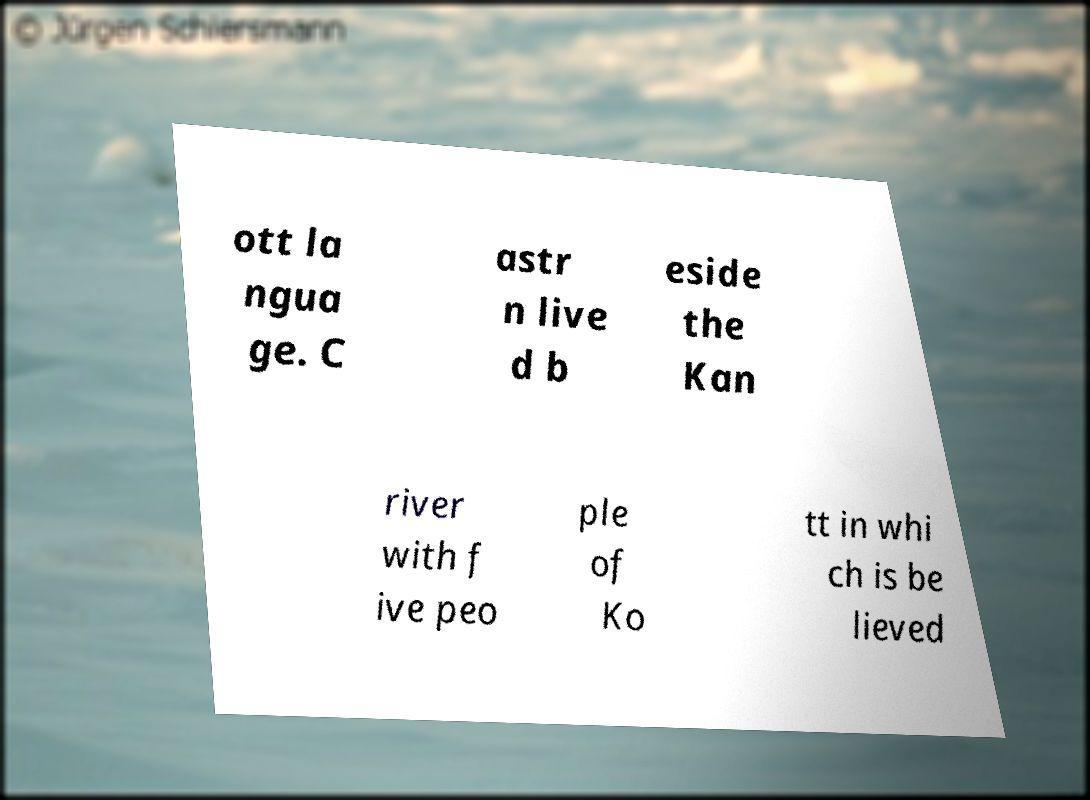Can you accurately transcribe the text from the provided image for me? ott la ngua ge. C astr n live d b eside the Kan river with f ive peo ple of Ko tt in whi ch is be lieved 